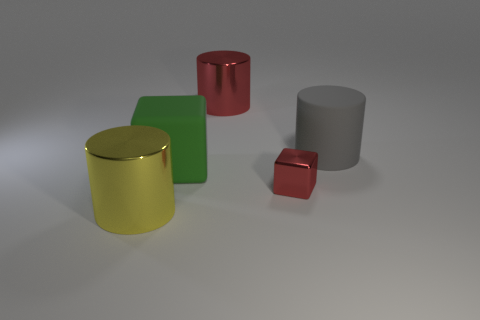Are there any other things that are the same size as the red block?
Keep it short and to the point. No. Are there any shiny cylinders of the same color as the small metal cube?
Make the answer very short. Yes. There is a red block that is made of the same material as the big red cylinder; what is its size?
Keep it short and to the point. Small. There is a large green object that is behind the metal cylinder in front of the large metallic thing behind the large gray object; what is its shape?
Your response must be concise. Cube. What size is the other object that is the same shape as the small object?
Your answer should be compact. Large. How big is the cylinder that is both behind the yellow cylinder and to the left of the big gray rubber thing?
Give a very brief answer. Large. The other object that is the same color as the small metallic thing is what shape?
Your answer should be compact. Cylinder. What is the color of the rubber cylinder?
Offer a terse response. Gray. There is a metal cylinder behind the big green rubber cube; what is its size?
Provide a short and direct response. Large. There is a big shiny cylinder behind the big thing in front of the red block; what number of cylinders are right of it?
Provide a short and direct response. 1. 